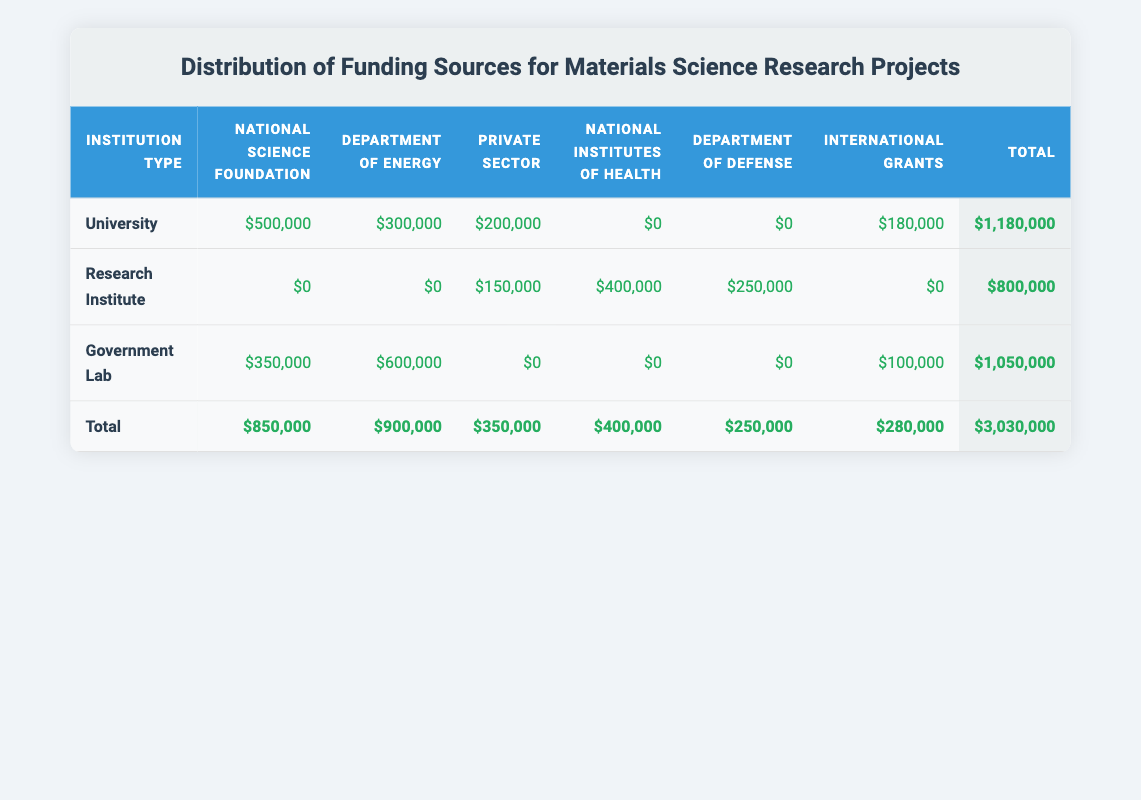What is the total funding amount received by Universities? The total funding amount received by Universities can be found in the last column of the row labeled "University." It shows $1,180,000 as the total amount allocated to Universities.
Answer: 1,180,000 Which funding source contributed the most to Government Labs? Looking at the row for Government Labs, the funding source with the highest amount is the Department of Energy with $600,000.
Answer: Department of Energy Is it true that Research Institutes received more funding from Private Sector compared to Universities? By comparing the respective amounts in the Private Sector column for both Research Institutes ($150,000) and Universities ($200,000), we can see that Universities received more funding from the Private Sector. Thus, the statement is false.
Answer: No What is the sum of the funding from National Science Foundation and Department of Defense across all institution types? First, we identify the amounts for the National Science Foundation ($850,000) and the Department of Defense ($250,000) from the totals at the bottom. Adding these gives us $850,000 + $250,000 = $1,100,000.
Answer: 1,100,000 Which institution type received the least total funding? The total funding can be found in the last column of each institution type row. Comparing them shows that Research Institutes have the lowest total funding amount of $800,000.
Answer: Research Institute How much funding is provided by International Grants to Universities? For Universities, the row indicates a funding total of $180,000 from the International Grants column.
Answer: 180,000 If we combine the funding from National Institutes of Health and Department of Defense for Research Institutes, how much total funding does that represent? For Research Institutes, the National Institutes of Health funding is $400,000 and the Department of Defense funding is $250,000. Adding these amounts gives $400,000 + $250,000 = $650,000.
Answer: 650,000 Do Government Labs have any funding from the National Institutes of Health? By looking at the Government Lab row under the National Institutes of Health, we see that the amount is $0. Therefore, there is no funding from this source for Government Labs.
Answer: No 